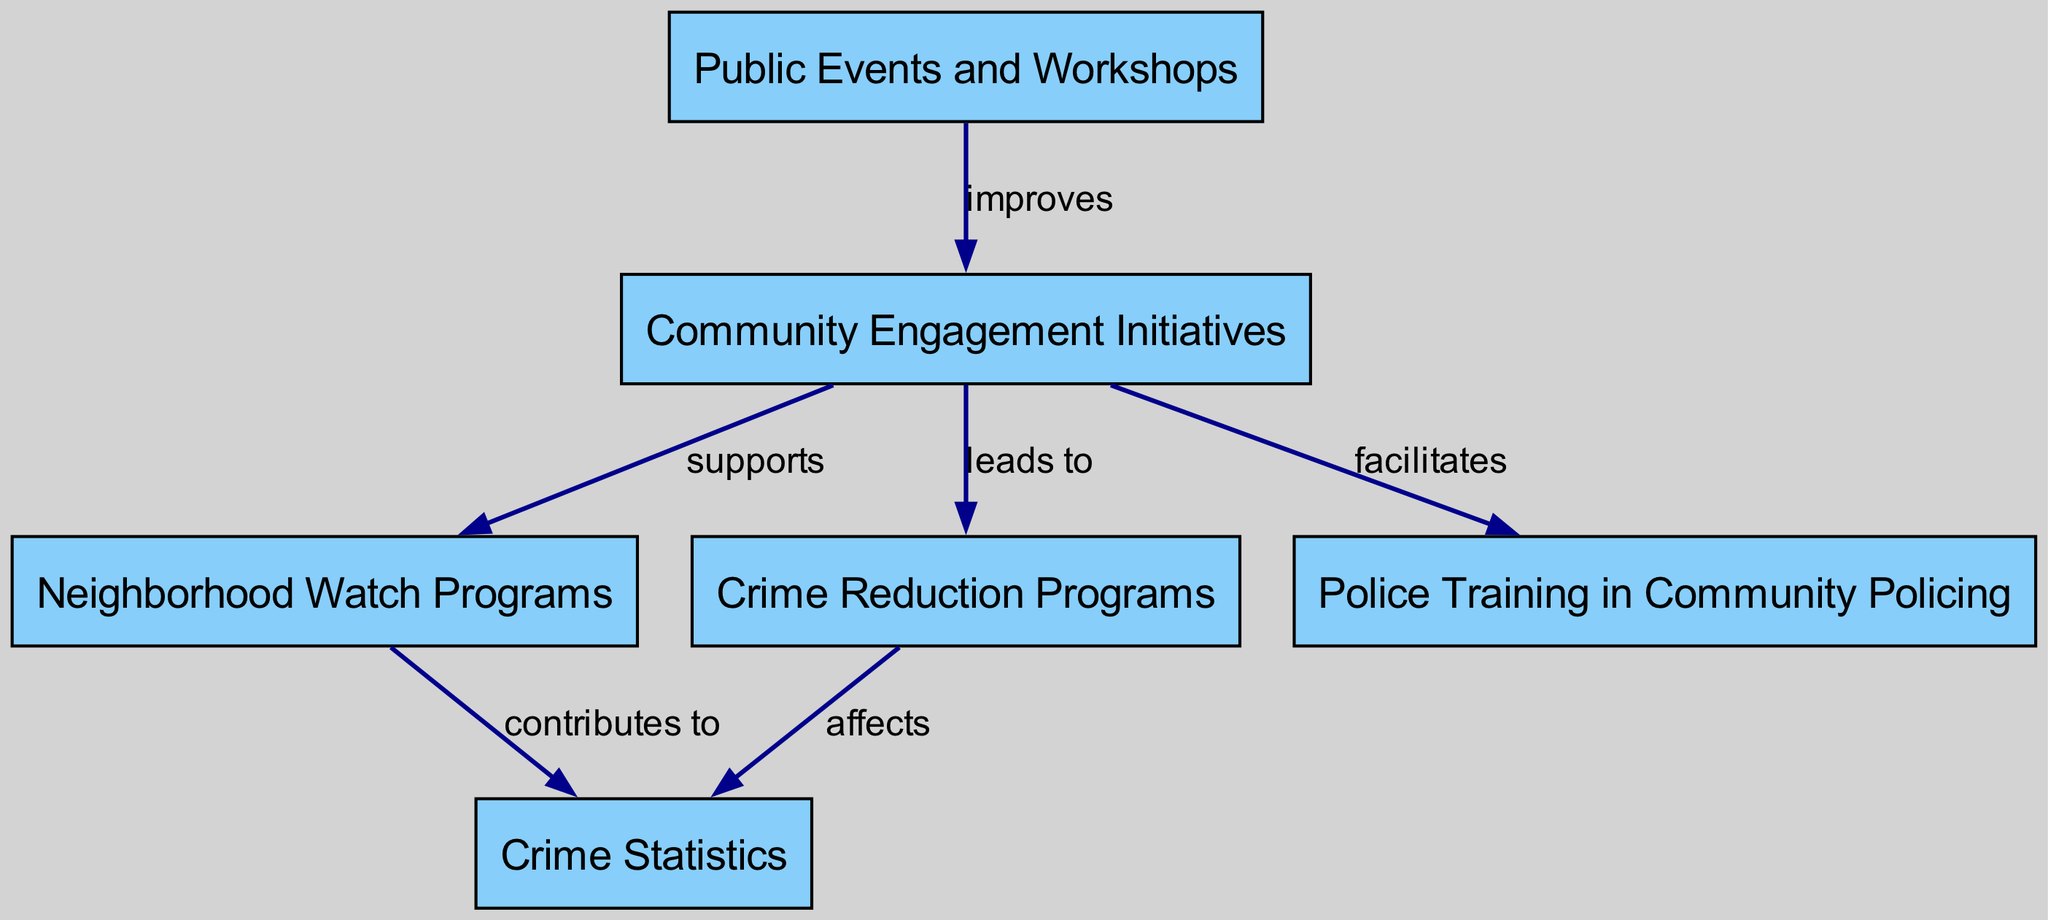What is the total number of nodes in the diagram? The diagram consists of six distinct nodes, each representing different aspects of community engagement and crime reduction initiatives.
Answer: 6 Which node supports Neighborhood Watch Programs? The arrow labeled "supports" from the "Community Engagement Initiatives" node points to the "Neighborhood Watch Programs" node, indicating that community engagement initiatives support neighborhood watch efforts.
Answer: Community Engagement Initiatives What effect do Crime Reduction Programs have on Crime Statistics? The diagram shows an edge labeled "affects" from the "Crime Reduction Programs" node to the "Crime Statistics" node, signifying that crime reduction programs have an impact on the statistics related to crime incidents.
Answer: affects How do Public Events and Workshops relate to Community Engagement Initiatives? The diagram illustrates a relationship where "Public Events and Workshops" improve "Community Engagement Initiatives," indicated by the edge labeled "improves," meaning that these events enhance community engagement efforts.
Answer: improves Which node is influenced by both Neighborhood Watch Programs and Crime Reduction Programs? "Crime Statistics" is influenced by both "Neighborhood Watch Programs," which contribute to it, and "Crime Reduction Programs," which affect it. The edges indicate that both initiatives impact crime data together.
Answer: Crime Statistics How are Police Training in Community Policing and Crime Reduction Programs connected? The connection can be traced as "Police Training in Community Policing" facilitates "Crime Reduction Programs," indicating that effective policing training leads to better crime reduction efforts.
Answer: facilitates Which node is the starting point for multiple connections in the diagram? The "Community Engagement Initiatives" node serves as the starting point for several connections, leading to "Neighborhood Watch Programs," "Crime Reduction Programs," and "Police Training in Community Policing."
Answer: Community Engagement Initiatives What type of initiatives do Neighborhood Watch Programs contribute to? The "Neighborhood Watch Programs" contribute to "Crime Statistics," as indicated by the directed edge in the diagram, linking local monitoring efforts with crime data reporting.
Answer: Crime Statistics 